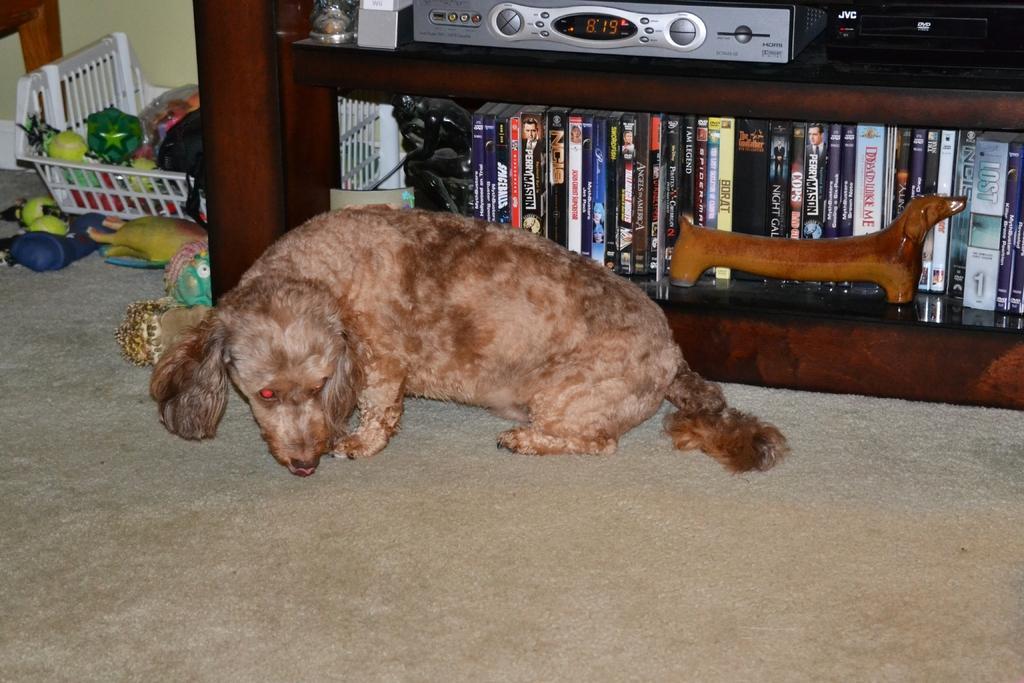Can you describe this image briefly? In the image we can see the dog, pale brown in color. We can even see there are books, kept on the shelf. Here we can see electronic device, basket and in the basket there are many other things and the carpet. 